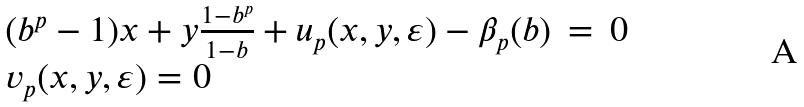<formula> <loc_0><loc_0><loc_500><loc_500>\begin{array} { l l l } ( b ^ { p } - 1 ) x + y \frac { 1 - b ^ { p } } { 1 - b } + u _ { p } ( x , y , \varepsilon ) - \beta _ { p } ( b ) & = & 0 \\ v _ { p } ( x , y , \varepsilon ) = 0 & & \end{array}</formula> 